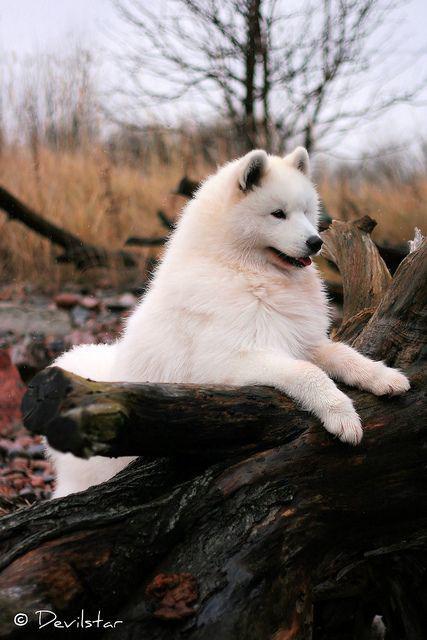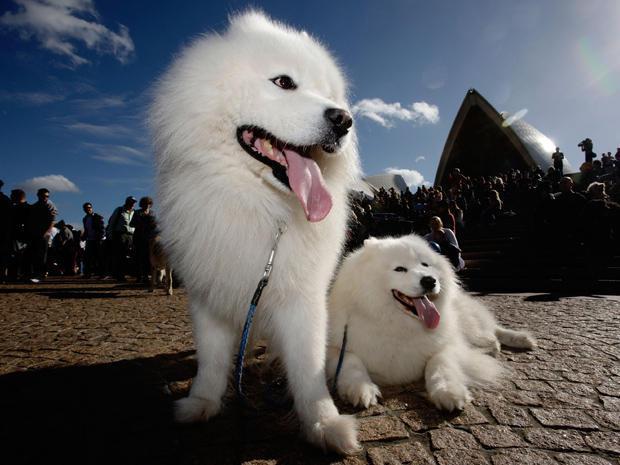The first image is the image on the left, the second image is the image on the right. For the images shown, is this caption "An image shows one person behind three white dogs." true? Answer yes or no. No. The first image is the image on the left, the second image is the image on the right. For the images shown, is this caption "There are three Samoyed puppies in the left image." true? Answer yes or no. No. 